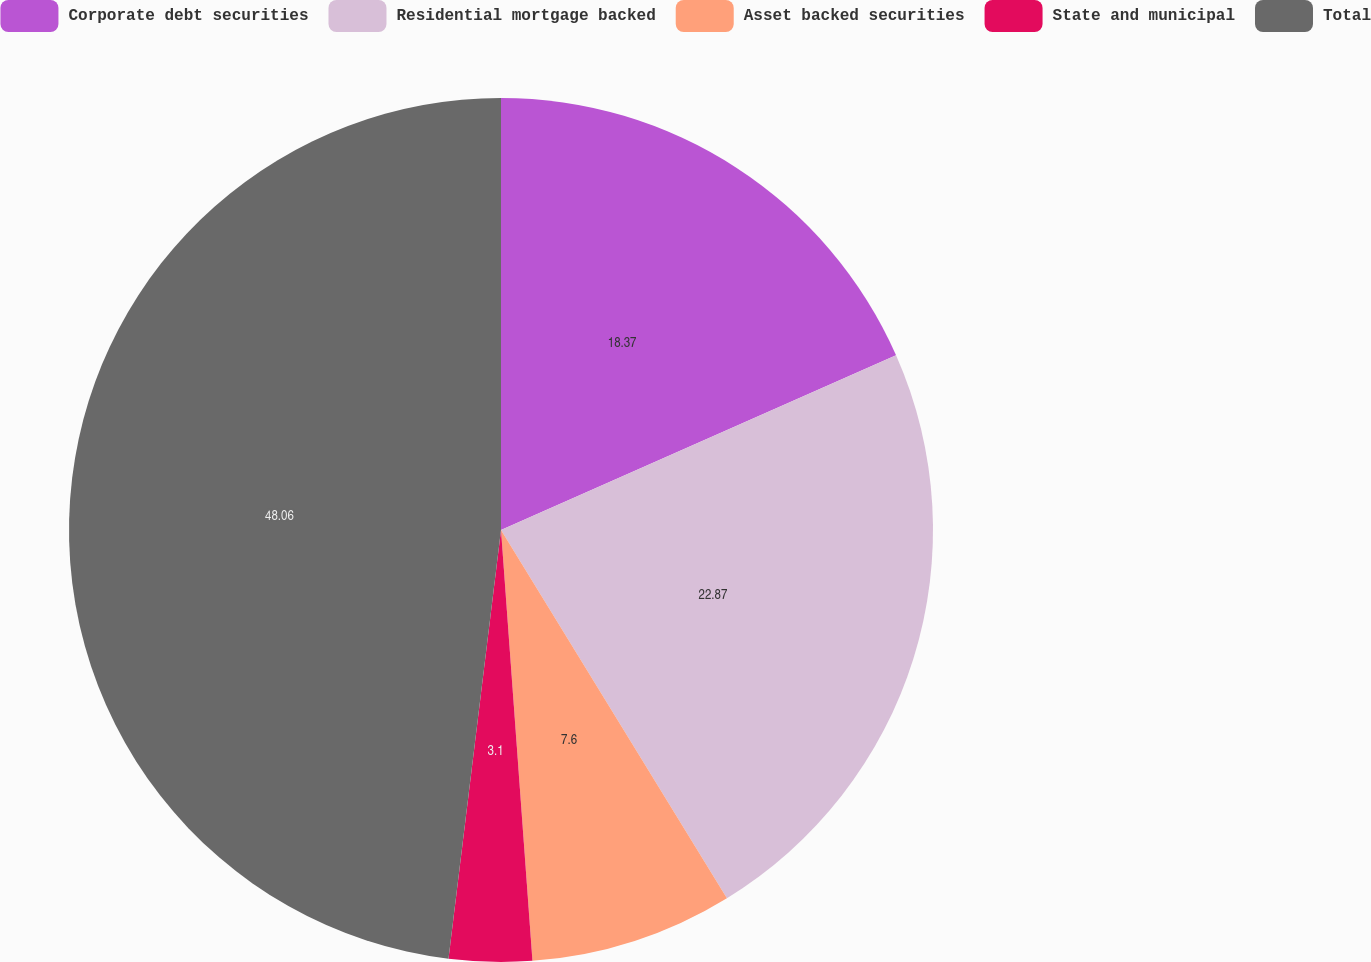Convert chart. <chart><loc_0><loc_0><loc_500><loc_500><pie_chart><fcel>Corporate debt securities<fcel>Residential mortgage backed<fcel>Asset backed securities<fcel>State and municipal<fcel>Total<nl><fcel>18.37%<fcel>22.87%<fcel>7.6%<fcel>3.1%<fcel>48.06%<nl></chart> 